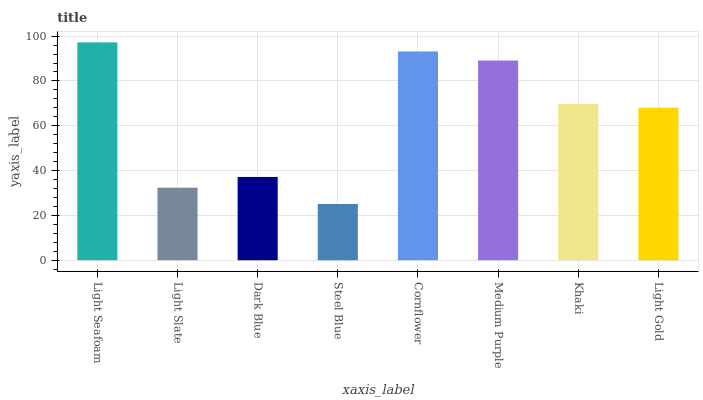Is Steel Blue the minimum?
Answer yes or no. Yes. Is Light Seafoam the maximum?
Answer yes or no. Yes. Is Light Slate the minimum?
Answer yes or no. No. Is Light Slate the maximum?
Answer yes or no. No. Is Light Seafoam greater than Light Slate?
Answer yes or no. Yes. Is Light Slate less than Light Seafoam?
Answer yes or no. Yes. Is Light Slate greater than Light Seafoam?
Answer yes or no. No. Is Light Seafoam less than Light Slate?
Answer yes or no. No. Is Khaki the high median?
Answer yes or no. Yes. Is Light Gold the low median?
Answer yes or no. Yes. Is Light Slate the high median?
Answer yes or no. No. Is Dark Blue the low median?
Answer yes or no. No. 